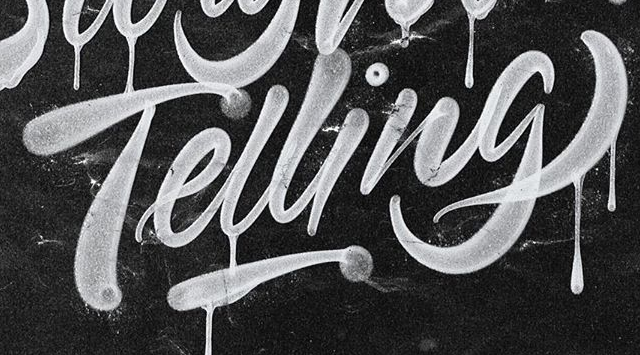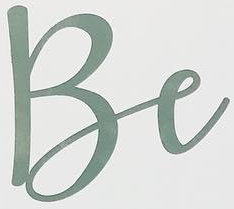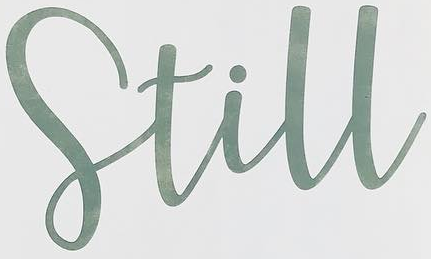Identify the words shown in these images in order, separated by a semicolon. Telling; Be; Still 